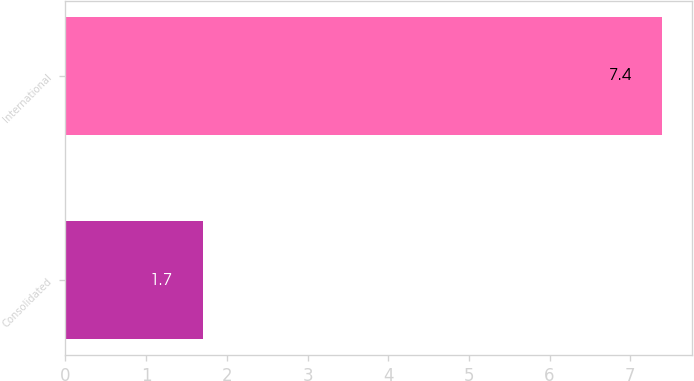<chart> <loc_0><loc_0><loc_500><loc_500><bar_chart><fcel>Consolidated<fcel>International<nl><fcel>1.7<fcel>7.4<nl></chart> 